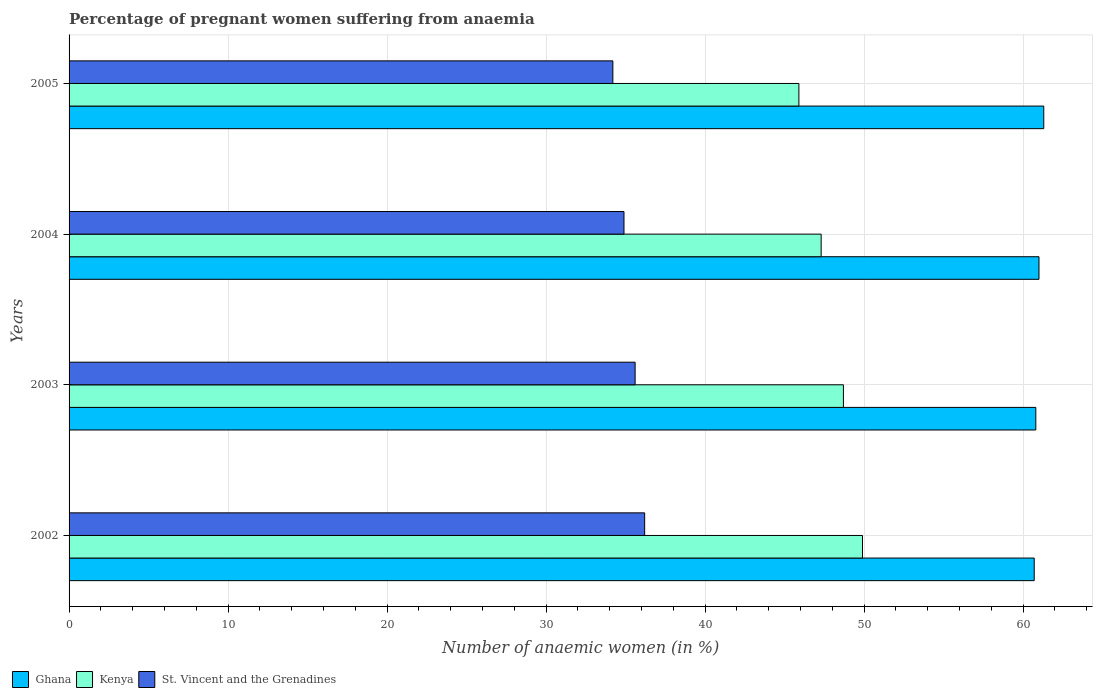How many groups of bars are there?
Your response must be concise. 4. Are the number of bars per tick equal to the number of legend labels?
Give a very brief answer. Yes. Are the number of bars on each tick of the Y-axis equal?
Provide a succinct answer. Yes. How many bars are there on the 2nd tick from the top?
Offer a terse response. 3. What is the label of the 3rd group of bars from the top?
Provide a short and direct response. 2003. In how many cases, is the number of bars for a given year not equal to the number of legend labels?
Keep it short and to the point. 0. What is the number of anaemic women in Kenya in 2003?
Ensure brevity in your answer.  48.7. Across all years, what is the maximum number of anaemic women in St. Vincent and the Grenadines?
Your response must be concise. 36.2. Across all years, what is the minimum number of anaemic women in Kenya?
Your response must be concise. 45.9. In which year was the number of anaemic women in Ghana maximum?
Give a very brief answer. 2005. In which year was the number of anaemic women in St. Vincent and the Grenadines minimum?
Your answer should be very brief. 2005. What is the total number of anaemic women in Ghana in the graph?
Your response must be concise. 243.8. What is the difference between the number of anaemic women in Kenya in 2003 and that in 2005?
Give a very brief answer. 2.8. What is the difference between the number of anaemic women in Ghana in 2003 and the number of anaemic women in St. Vincent and the Grenadines in 2002?
Provide a succinct answer. 24.6. What is the average number of anaemic women in Ghana per year?
Offer a very short reply. 60.95. In the year 2004, what is the difference between the number of anaemic women in Kenya and number of anaemic women in St. Vincent and the Grenadines?
Offer a terse response. 12.4. What is the ratio of the number of anaemic women in Kenya in 2003 to that in 2004?
Your answer should be compact. 1.03. Is the number of anaemic women in Ghana in 2003 less than that in 2004?
Offer a terse response. Yes. What is the difference between the highest and the second highest number of anaemic women in St. Vincent and the Grenadines?
Your response must be concise. 0.6. What is the difference between the highest and the lowest number of anaemic women in St. Vincent and the Grenadines?
Ensure brevity in your answer.  2. In how many years, is the number of anaemic women in St. Vincent and the Grenadines greater than the average number of anaemic women in St. Vincent and the Grenadines taken over all years?
Offer a terse response. 2. Is the sum of the number of anaemic women in Ghana in 2004 and 2005 greater than the maximum number of anaemic women in Kenya across all years?
Give a very brief answer. Yes. What does the 3rd bar from the top in 2002 represents?
Your answer should be compact. Ghana. Are all the bars in the graph horizontal?
Give a very brief answer. Yes. Are the values on the major ticks of X-axis written in scientific E-notation?
Ensure brevity in your answer.  No. Does the graph contain any zero values?
Provide a short and direct response. No. What is the title of the graph?
Offer a very short reply. Percentage of pregnant women suffering from anaemia. What is the label or title of the X-axis?
Ensure brevity in your answer.  Number of anaemic women (in %). What is the label or title of the Y-axis?
Make the answer very short. Years. What is the Number of anaemic women (in %) of Ghana in 2002?
Keep it short and to the point. 60.7. What is the Number of anaemic women (in %) of Kenya in 2002?
Make the answer very short. 49.9. What is the Number of anaemic women (in %) in St. Vincent and the Grenadines in 2002?
Offer a terse response. 36.2. What is the Number of anaemic women (in %) in Ghana in 2003?
Make the answer very short. 60.8. What is the Number of anaemic women (in %) in Kenya in 2003?
Give a very brief answer. 48.7. What is the Number of anaemic women (in %) in St. Vincent and the Grenadines in 2003?
Ensure brevity in your answer.  35.6. What is the Number of anaemic women (in %) of Kenya in 2004?
Make the answer very short. 47.3. What is the Number of anaemic women (in %) of St. Vincent and the Grenadines in 2004?
Offer a terse response. 34.9. What is the Number of anaemic women (in %) in Ghana in 2005?
Offer a terse response. 61.3. What is the Number of anaemic women (in %) of Kenya in 2005?
Your answer should be compact. 45.9. What is the Number of anaemic women (in %) in St. Vincent and the Grenadines in 2005?
Offer a very short reply. 34.2. Across all years, what is the maximum Number of anaemic women (in %) in Ghana?
Offer a terse response. 61.3. Across all years, what is the maximum Number of anaemic women (in %) of Kenya?
Provide a short and direct response. 49.9. Across all years, what is the maximum Number of anaemic women (in %) in St. Vincent and the Grenadines?
Your answer should be very brief. 36.2. Across all years, what is the minimum Number of anaemic women (in %) of Ghana?
Make the answer very short. 60.7. Across all years, what is the minimum Number of anaemic women (in %) in Kenya?
Your answer should be very brief. 45.9. Across all years, what is the minimum Number of anaemic women (in %) in St. Vincent and the Grenadines?
Your answer should be very brief. 34.2. What is the total Number of anaemic women (in %) in Ghana in the graph?
Offer a very short reply. 243.8. What is the total Number of anaemic women (in %) in Kenya in the graph?
Provide a succinct answer. 191.8. What is the total Number of anaemic women (in %) in St. Vincent and the Grenadines in the graph?
Offer a very short reply. 140.9. What is the difference between the Number of anaemic women (in %) in Ghana in 2002 and that in 2003?
Make the answer very short. -0.1. What is the difference between the Number of anaemic women (in %) of Kenya in 2002 and that in 2003?
Offer a terse response. 1.2. What is the difference between the Number of anaemic women (in %) in Ghana in 2002 and that in 2004?
Make the answer very short. -0.3. What is the difference between the Number of anaemic women (in %) in St. Vincent and the Grenadines in 2002 and that in 2004?
Your response must be concise. 1.3. What is the difference between the Number of anaemic women (in %) in St. Vincent and the Grenadines in 2002 and that in 2005?
Give a very brief answer. 2. What is the difference between the Number of anaemic women (in %) in St. Vincent and the Grenadines in 2003 and that in 2005?
Your answer should be compact. 1.4. What is the difference between the Number of anaemic women (in %) in St. Vincent and the Grenadines in 2004 and that in 2005?
Provide a short and direct response. 0.7. What is the difference between the Number of anaemic women (in %) in Ghana in 2002 and the Number of anaemic women (in %) in Kenya in 2003?
Give a very brief answer. 12. What is the difference between the Number of anaemic women (in %) of Ghana in 2002 and the Number of anaemic women (in %) of St. Vincent and the Grenadines in 2003?
Offer a terse response. 25.1. What is the difference between the Number of anaemic women (in %) of Ghana in 2002 and the Number of anaemic women (in %) of Kenya in 2004?
Your answer should be compact. 13.4. What is the difference between the Number of anaemic women (in %) in Ghana in 2002 and the Number of anaemic women (in %) in St. Vincent and the Grenadines in 2004?
Offer a very short reply. 25.8. What is the difference between the Number of anaemic women (in %) in Ghana in 2002 and the Number of anaemic women (in %) in Kenya in 2005?
Provide a short and direct response. 14.8. What is the difference between the Number of anaemic women (in %) of Ghana in 2002 and the Number of anaemic women (in %) of St. Vincent and the Grenadines in 2005?
Your answer should be very brief. 26.5. What is the difference between the Number of anaemic women (in %) in Ghana in 2003 and the Number of anaemic women (in %) in St. Vincent and the Grenadines in 2004?
Make the answer very short. 25.9. What is the difference between the Number of anaemic women (in %) in Kenya in 2003 and the Number of anaemic women (in %) in St. Vincent and the Grenadines in 2004?
Offer a terse response. 13.8. What is the difference between the Number of anaemic women (in %) of Ghana in 2003 and the Number of anaemic women (in %) of Kenya in 2005?
Offer a terse response. 14.9. What is the difference between the Number of anaemic women (in %) in Ghana in 2003 and the Number of anaemic women (in %) in St. Vincent and the Grenadines in 2005?
Your answer should be very brief. 26.6. What is the difference between the Number of anaemic women (in %) in Ghana in 2004 and the Number of anaemic women (in %) in St. Vincent and the Grenadines in 2005?
Offer a terse response. 26.8. What is the difference between the Number of anaemic women (in %) in Kenya in 2004 and the Number of anaemic women (in %) in St. Vincent and the Grenadines in 2005?
Keep it short and to the point. 13.1. What is the average Number of anaemic women (in %) of Ghana per year?
Provide a short and direct response. 60.95. What is the average Number of anaemic women (in %) in Kenya per year?
Provide a short and direct response. 47.95. What is the average Number of anaemic women (in %) of St. Vincent and the Grenadines per year?
Your answer should be very brief. 35.23. In the year 2002, what is the difference between the Number of anaemic women (in %) of Ghana and Number of anaemic women (in %) of St. Vincent and the Grenadines?
Ensure brevity in your answer.  24.5. In the year 2003, what is the difference between the Number of anaemic women (in %) in Ghana and Number of anaemic women (in %) in St. Vincent and the Grenadines?
Keep it short and to the point. 25.2. In the year 2004, what is the difference between the Number of anaemic women (in %) in Ghana and Number of anaemic women (in %) in St. Vincent and the Grenadines?
Offer a very short reply. 26.1. In the year 2005, what is the difference between the Number of anaemic women (in %) of Ghana and Number of anaemic women (in %) of St. Vincent and the Grenadines?
Your answer should be very brief. 27.1. What is the ratio of the Number of anaemic women (in %) in Kenya in 2002 to that in 2003?
Offer a very short reply. 1.02. What is the ratio of the Number of anaemic women (in %) of St. Vincent and the Grenadines in 2002 to that in 2003?
Give a very brief answer. 1.02. What is the ratio of the Number of anaemic women (in %) of Ghana in 2002 to that in 2004?
Keep it short and to the point. 1. What is the ratio of the Number of anaemic women (in %) of Kenya in 2002 to that in 2004?
Keep it short and to the point. 1.05. What is the ratio of the Number of anaemic women (in %) of St. Vincent and the Grenadines in 2002 to that in 2004?
Provide a succinct answer. 1.04. What is the ratio of the Number of anaemic women (in %) in Ghana in 2002 to that in 2005?
Offer a very short reply. 0.99. What is the ratio of the Number of anaemic women (in %) of Kenya in 2002 to that in 2005?
Offer a terse response. 1.09. What is the ratio of the Number of anaemic women (in %) in St. Vincent and the Grenadines in 2002 to that in 2005?
Make the answer very short. 1.06. What is the ratio of the Number of anaemic women (in %) of Kenya in 2003 to that in 2004?
Provide a short and direct response. 1.03. What is the ratio of the Number of anaemic women (in %) in St. Vincent and the Grenadines in 2003 to that in 2004?
Give a very brief answer. 1.02. What is the ratio of the Number of anaemic women (in %) in Kenya in 2003 to that in 2005?
Keep it short and to the point. 1.06. What is the ratio of the Number of anaemic women (in %) in St. Vincent and the Grenadines in 2003 to that in 2005?
Provide a short and direct response. 1.04. What is the ratio of the Number of anaemic women (in %) in Kenya in 2004 to that in 2005?
Make the answer very short. 1.03. What is the ratio of the Number of anaemic women (in %) of St. Vincent and the Grenadines in 2004 to that in 2005?
Your answer should be compact. 1.02. What is the difference between the highest and the second highest Number of anaemic women (in %) in Ghana?
Make the answer very short. 0.3. What is the difference between the highest and the lowest Number of anaemic women (in %) in Ghana?
Give a very brief answer. 0.6. 